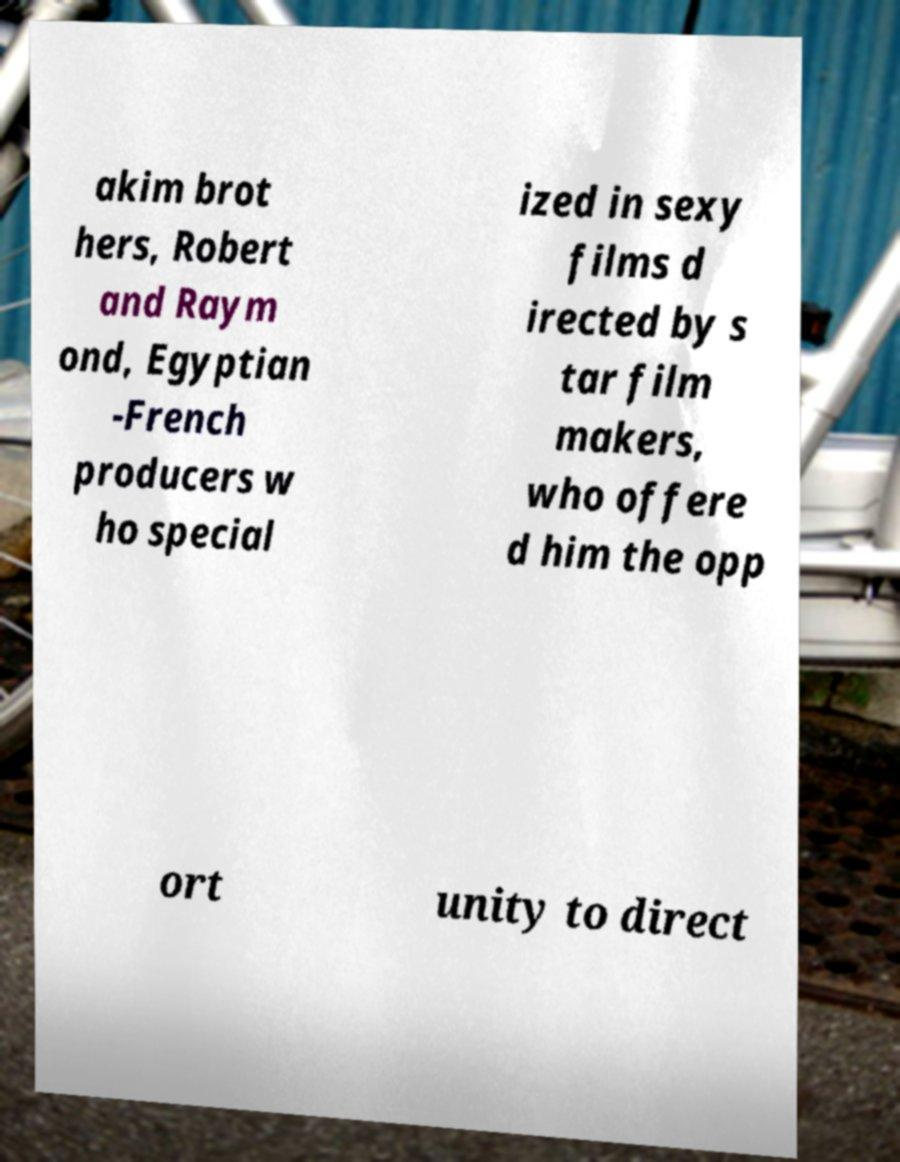Can you read and provide the text displayed in the image?This photo seems to have some interesting text. Can you extract and type it out for me? akim brot hers, Robert and Raym ond, Egyptian -French producers w ho special ized in sexy films d irected by s tar film makers, who offere d him the opp ort unity to direct 